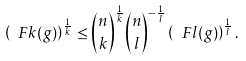Convert formula to latex. <formula><loc_0><loc_0><loc_500><loc_500>\left ( \ F k ( g ) \right ) ^ { \frac { 1 } { k } } \leq { \binom { n } { k } } ^ { \frac { 1 } { k } } { \binom { n } { l } } ^ { - \frac { 1 } { l } } \left ( \ F l ( g ) \right ) ^ { \frac { 1 } { l } } .</formula> 